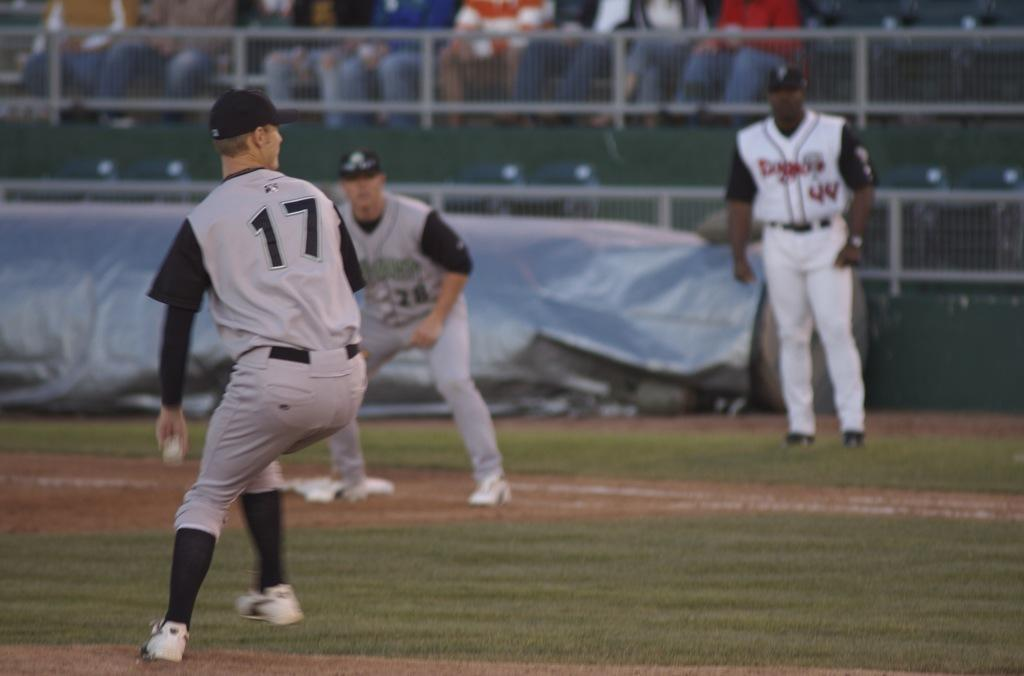<image>
Render a clear and concise summary of the photo. Player 17 is getting ready to throw a ball in a baseball field. 